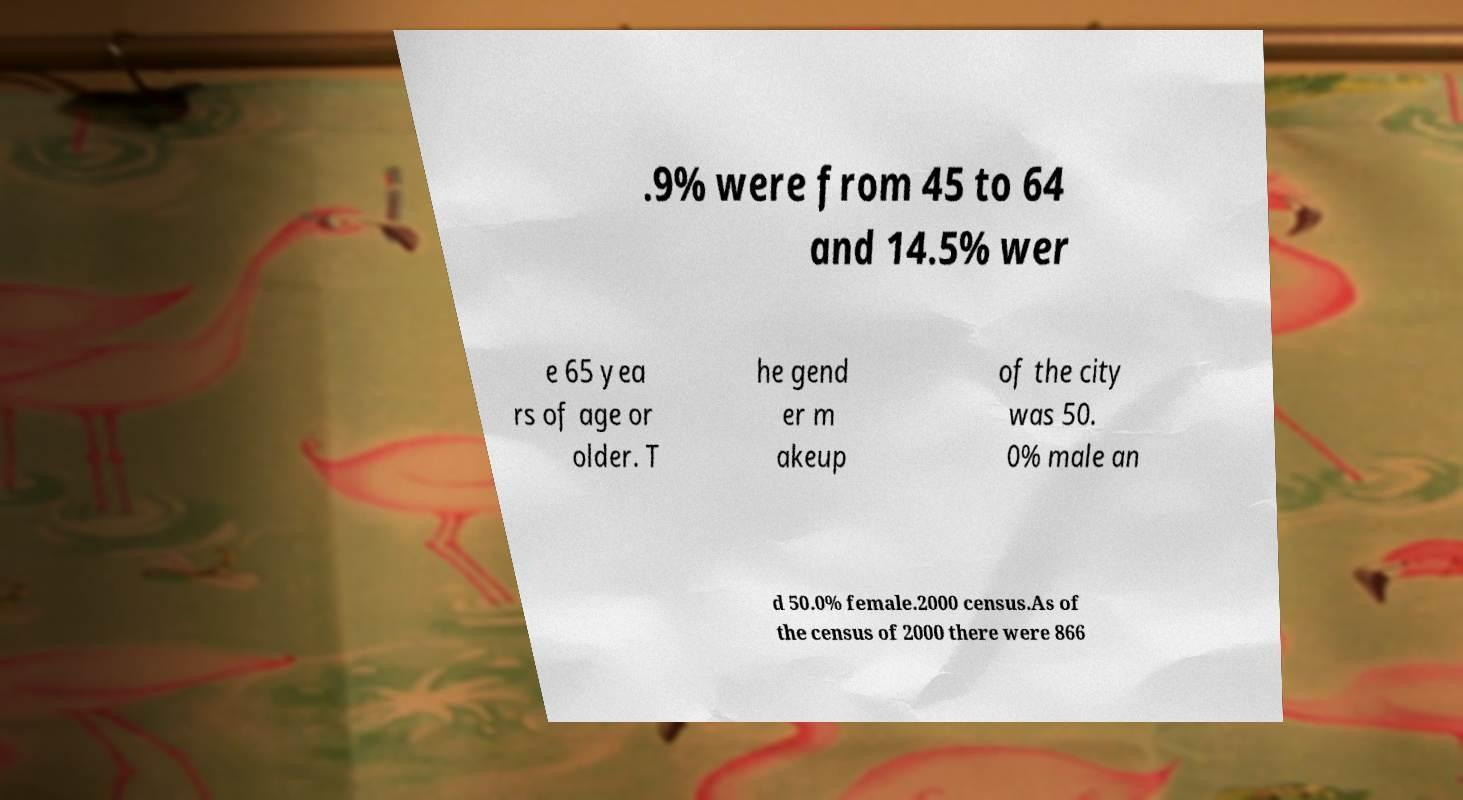There's text embedded in this image that I need extracted. Can you transcribe it verbatim? .9% were from 45 to 64 and 14.5% wer e 65 yea rs of age or older. T he gend er m akeup of the city was 50. 0% male an d 50.0% female.2000 census.As of the census of 2000 there were 866 